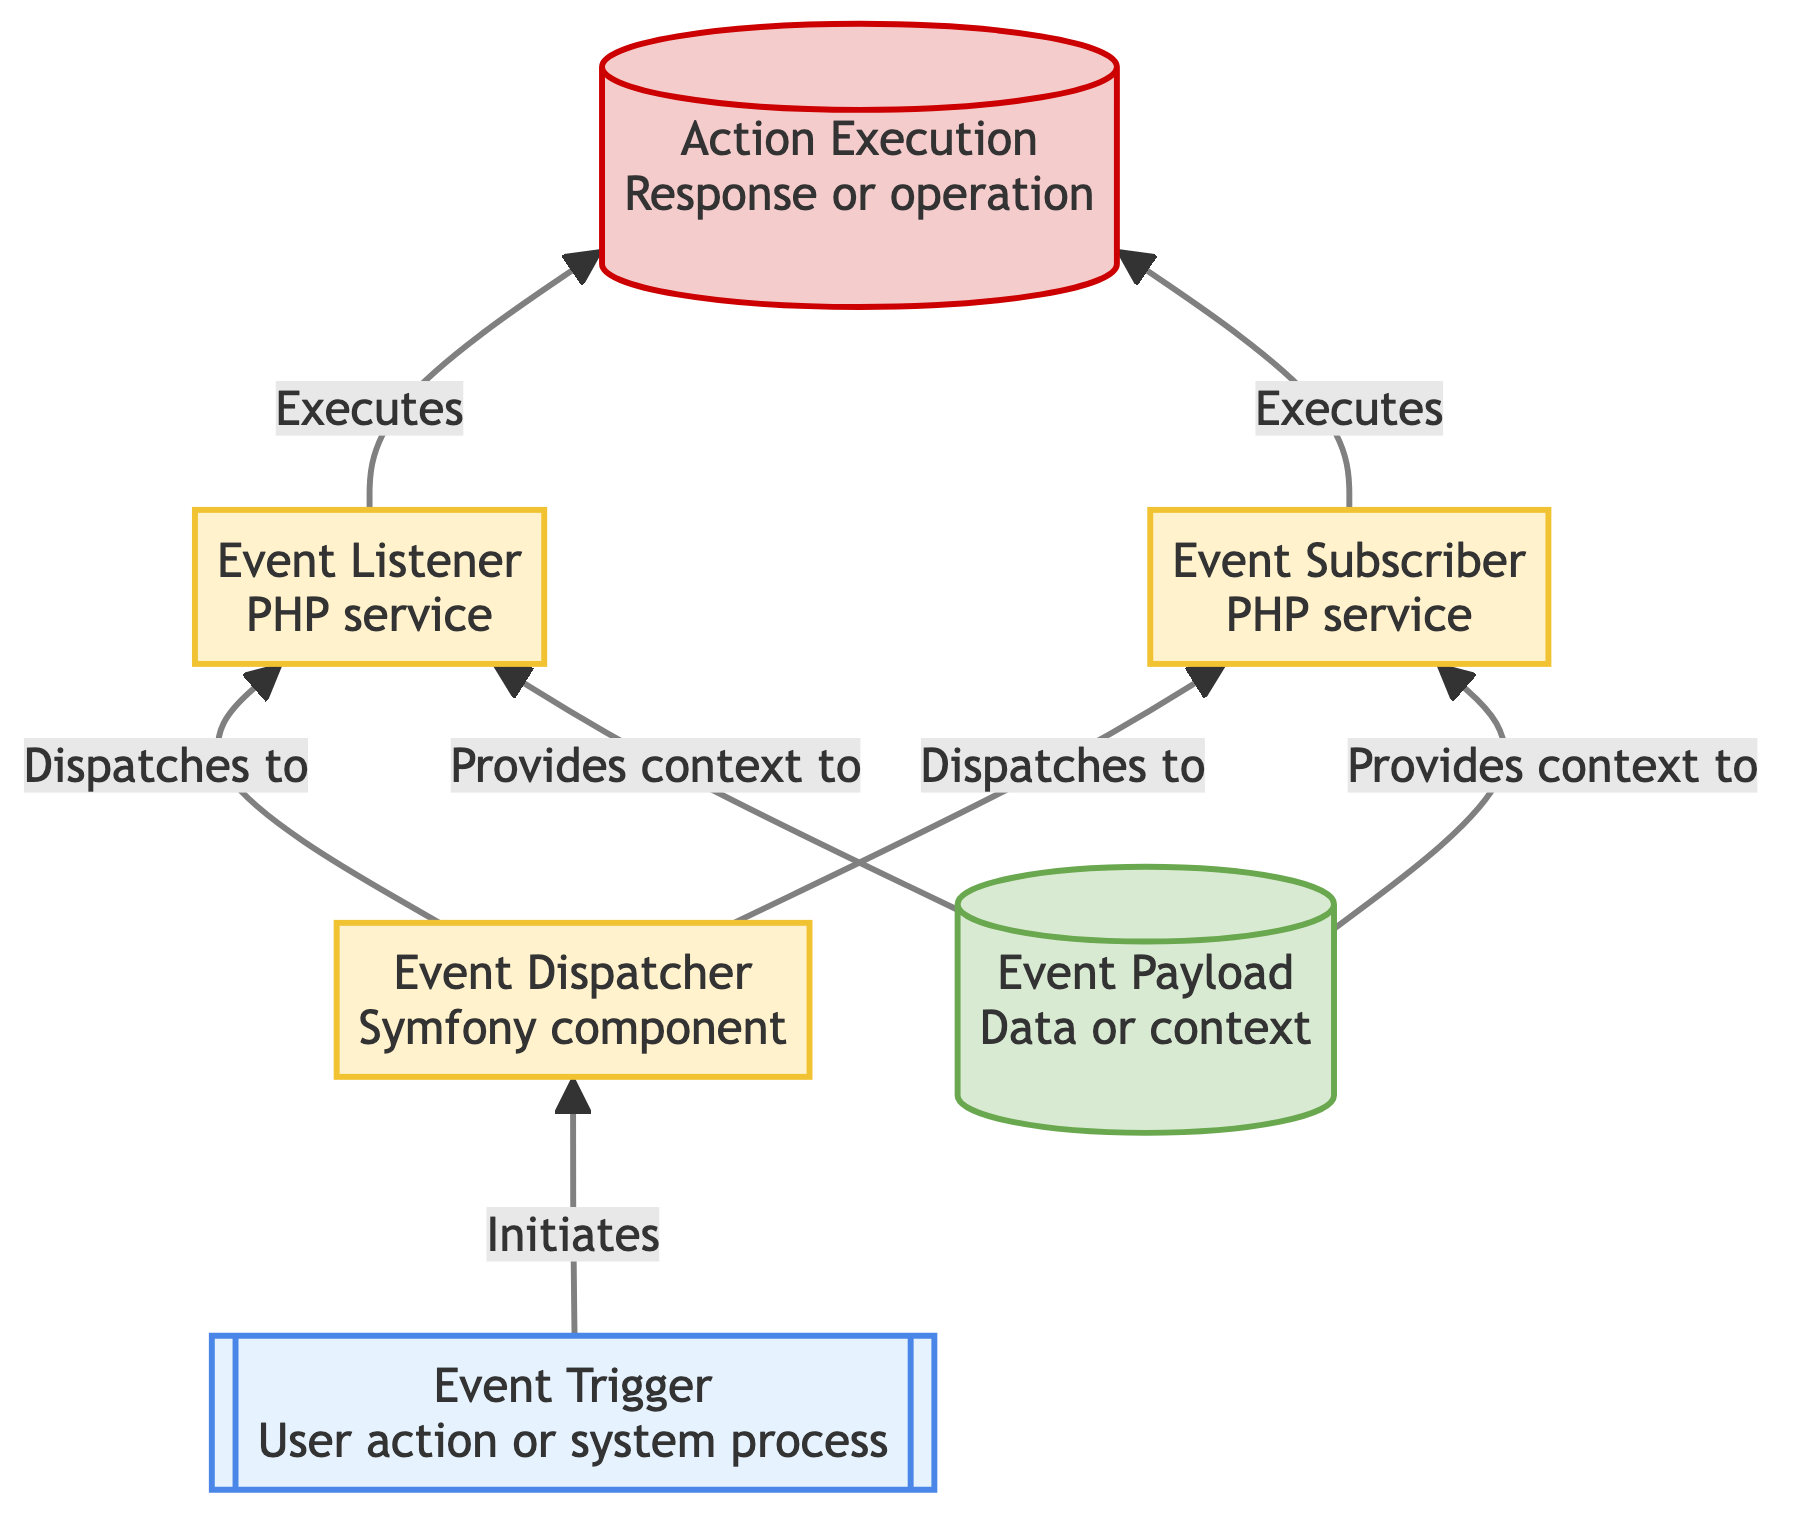What initiates the workflow in this diagram? The workflow is initiated by the "Event Trigger," which represents a user action or system process. It serves as the starting point that activates the subsequent steps in the event handling workflow.
Answer: Event Trigger How many processes are depicted in the diagram? There are three processes shown in the diagram: "Event Dispatcher," "Event Listener," and "Event Subscriber." Each of these plays a distinct role in handling the event once triggered.
Answer: 3 What type of element is "Event Payload"? In the diagram, "Event Payload" is classified as a data type, as it contains the data or context, such as user data or order details, that is necessary for processing the event.
Answer: data Which element executes the final action? The final action is executed by both the "Event Listener" and "Event Subscriber." Each of these elements performs a specific response or operation as a result of processing the event.
Answer: Event Listener and Event Subscriber What relationship does the Event Dispatcher have with the Event Listener? The "Event Dispatcher" has a relationship of dispatching events to the "Event Listener." This means it forwards the triggered event to the listener for processing.
Answer: Dispatches to Which element provides context to both the Event Listener and Event Subscriber? The "Event Payload" provides context to both the "Event Listener" and "Event Subscriber." It contains the necessary data that allows these elements to process the event accurately.
Answer: Event Payload Which type of element initiates the event handling process? The element that initiates the event handling process is the "Event Trigger." It serves as the starting point for the workflow by generating an event that needs to be processed.
Answer: Event Trigger What is the output of the event handling workflow? The output of the event handling workflow is "Action Execution." This represents the final response or operation that occurs as a result of the event processing, such as sending an email or updating a database.
Answer: Action Execution How many edges connect the Event Dispatcher to other elements? There are four edges connecting the "Event Dispatcher" to other elements: it dispatches events to both the "Event Listener" and "Event Subscriber" and receives context from "Event Payload."
Answer: 4 